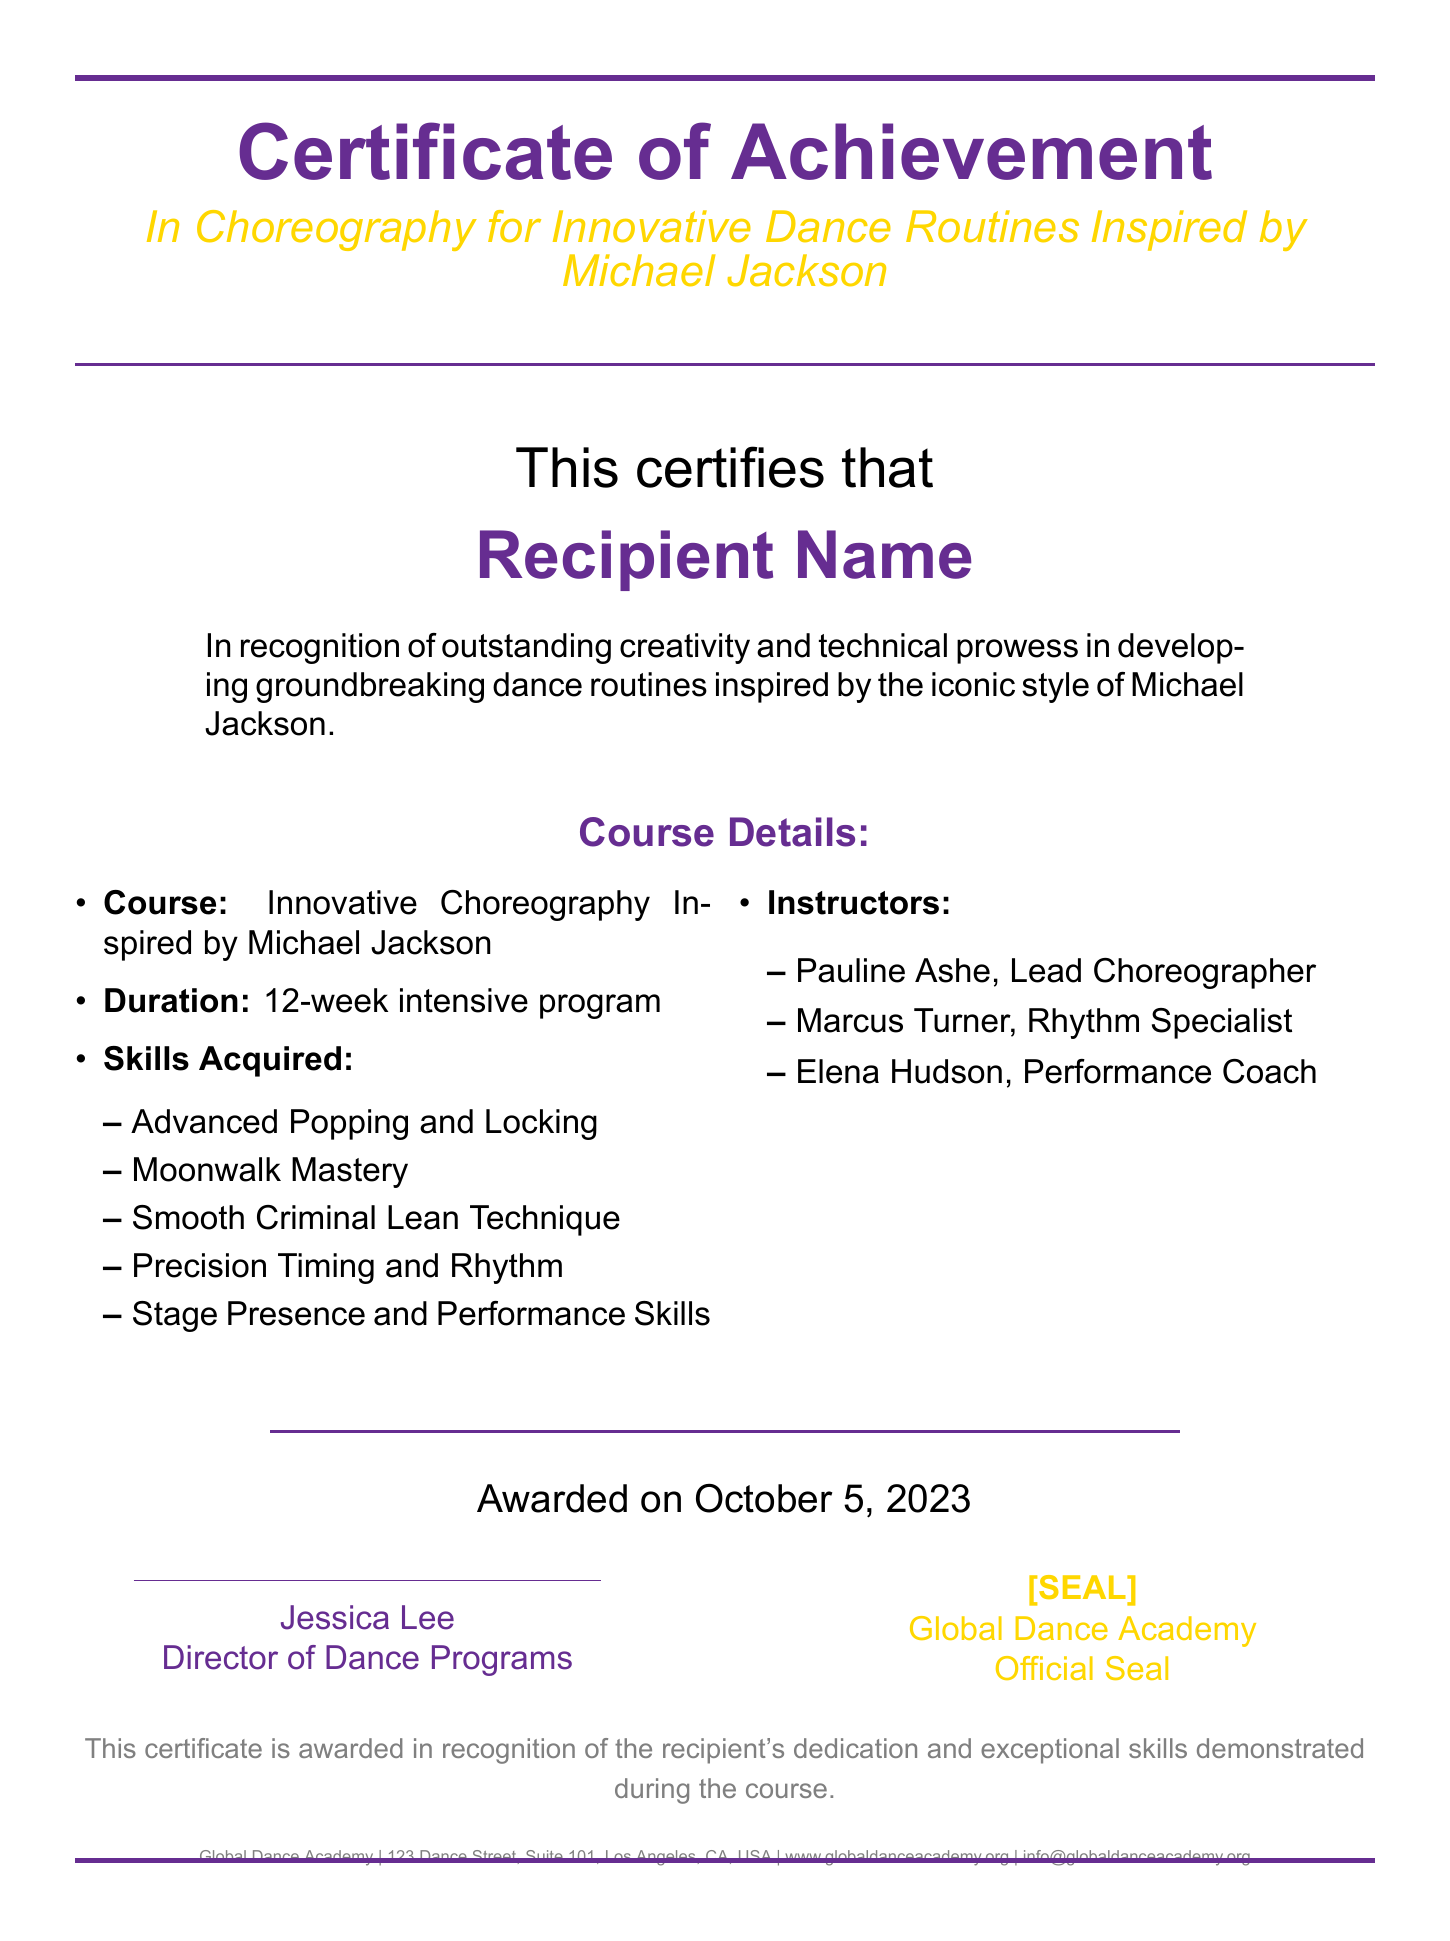What is the title of the certificate? The title of the certificate is located at the top, stating its purpose.
Answer: Certificate of Achievement Who is the recipient name placeholder? The document has a placeholder for the name of the recipient.
Answer: Recipient Name How many weeks does the course last? The duration of the course is mentioned in the document.
Answer: 12-week Name one skill acquired in the course. The document lists several skills the participants would acquire during the course.
Answer: Moonwalk Mastery Who is the lead choreographer? The names of the instructors are listed in the course details section.
Answer: Pauline Ashe When was the certificate awarded? The awarded date is clearly specified on the document.
Answer: October 5, 2023 What is the official seal? The certificate includes an official seal to signify authenticity.
Answer: [SEAL] Which organization issued this certificate? The footer of the document indicates the organization responsible for the certificate.
Answer: Global Dance Academy What color is used for the header text? The document mentions a specific color for the header, describing its appearance.
Answer: mjpurple 